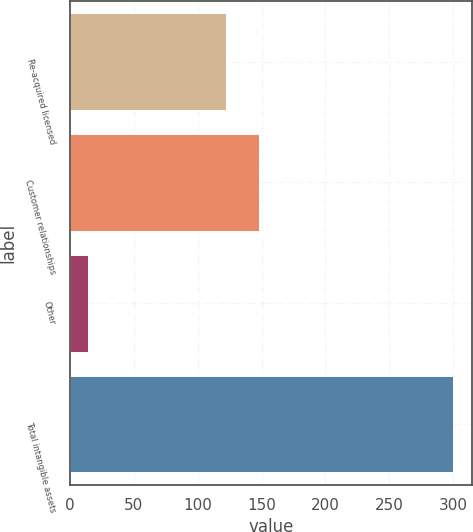<chart> <loc_0><loc_0><loc_500><loc_500><bar_chart><fcel>Re-acquired licensed<fcel>Customer relationships<fcel>Other<fcel>Total intangible assets<nl><fcel>122<fcel>148<fcel>14<fcel>300<nl></chart> 